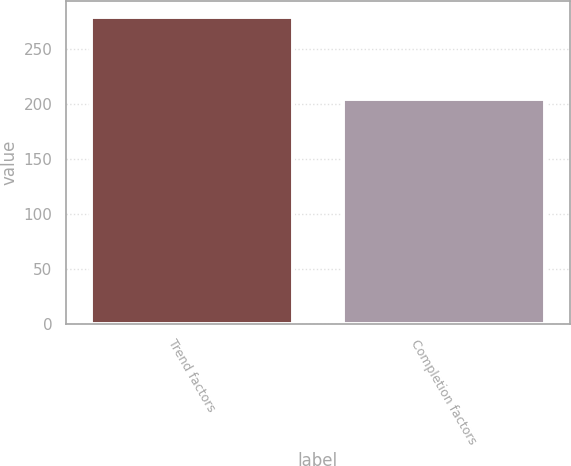Convert chart to OTSL. <chart><loc_0><loc_0><loc_500><loc_500><bar_chart><fcel>Trend factors<fcel>Completion factors<nl><fcel>279<fcel>204<nl></chart> 